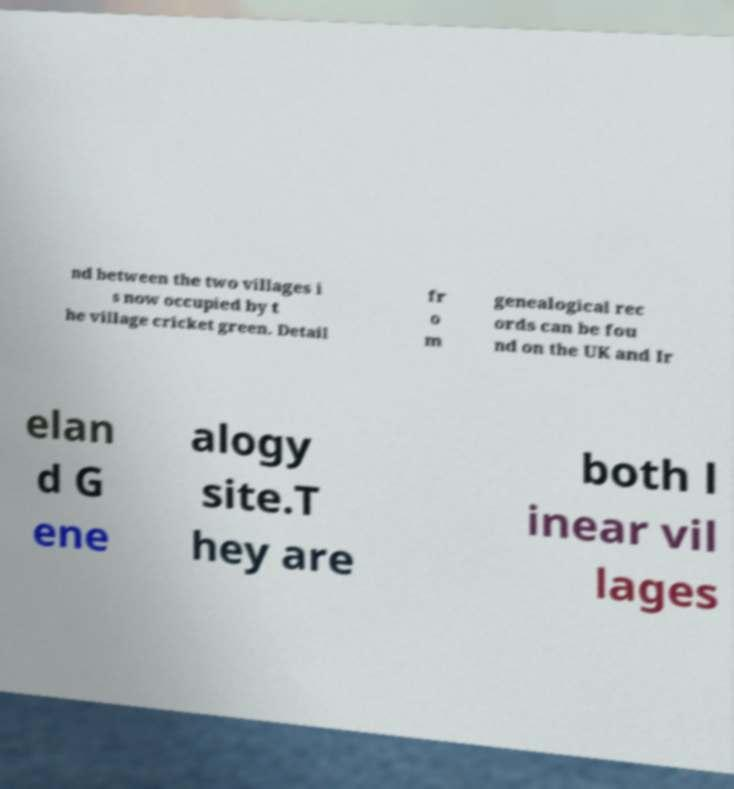Can you read and provide the text displayed in the image?This photo seems to have some interesting text. Can you extract and type it out for me? nd between the two villages i s now occupied by t he village cricket green. Detail fr o m genealogical rec ords can be fou nd on the UK and Ir elan d G ene alogy site.T hey are both l inear vil lages 